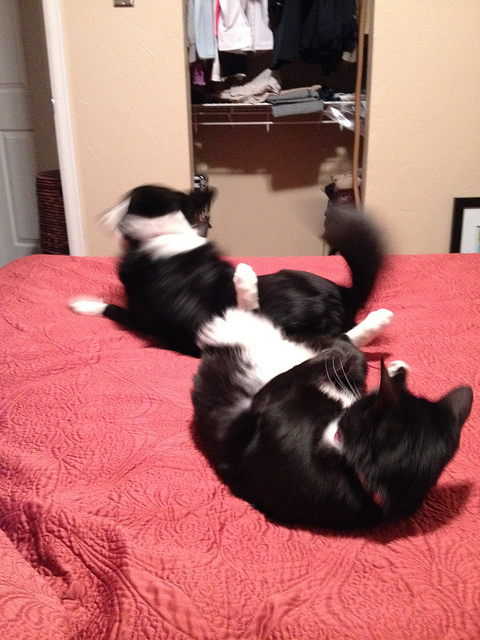What are the two animals doing in this picture? The two animals, which are cats, seem to be playfully interacting with each other on a bed. One of them is caught mid-motion, perhaps in the midst of a playful pounce or a gentle swipe at the other, contributing to a dynamic and affectionate moment between them. 